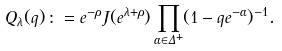<formula> <loc_0><loc_0><loc_500><loc_500>Q _ { \lambda } ( q ) \, \colon = e ^ { - \rho } J ( e ^ { \lambda + \rho } ) \prod _ { \alpha \in \Delta ^ { + } } ( 1 - q e ^ { - \alpha } ) ^ { - 1 } .</formula> 